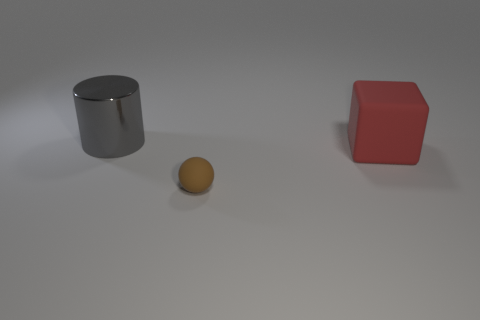Is there any other thing that has the same material as the gray thing?
Give a very brief answer. No. How many things are big objects in front of the big gray thing or big objects that are on the right side of the big metallic object?
Offer a terse response. 1. Is the number of tiny cyan rubber cylinders less than the number of big rubber things?
Keep it short and to the point. Yes. What is the material of the other object that is the same size as the red rubber thing?
Keep it short and to the point. Metal. Does the thing that is on the left side of the brown rubber object have the same size as the matte thing behind the small brown sphere?
Offer a very short reply. Yes. Are there any purple cubes made of the same material as the sphere?
Offer a very short reply. No. How many things are rubber things that are in front of the large red matte block or shiny blocks?
Provide a succinct answer. 1. Do the big thing that is right of the big shiny thing and the brown sphere have the same material?
Offer a terse response. Yes. Does the tiny matte object have the same shape as the large red matte object?
Offer a very short reply. No. There is a large thing that is in front of the gray cylinder; how many big red things are behind it?
Provide a succinct answer. 0. 